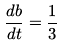Convert formula to latex. <formula><loc_0><loc_0><loc_500><loc_500>\frac { d b } { d t } = \frac { 1 } { 3 }</formula> 